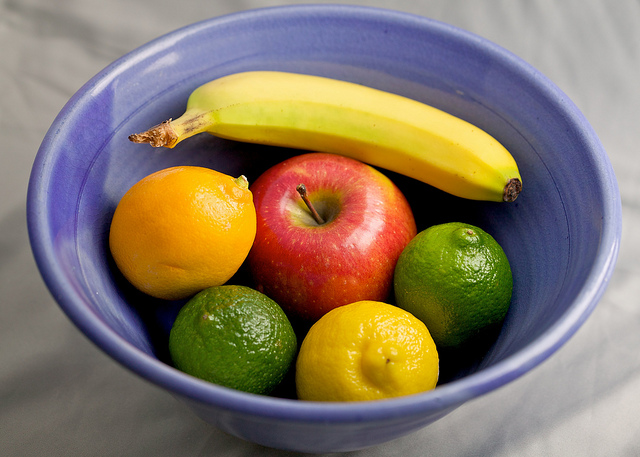<image>What face does the topmost fruit have? I don't know what kind of face the topmost fruit has. It might not have any face. What face does the topmost fruit have? There is no face on the topmost fruit. However, it can be seen a banana or a smiley face. 